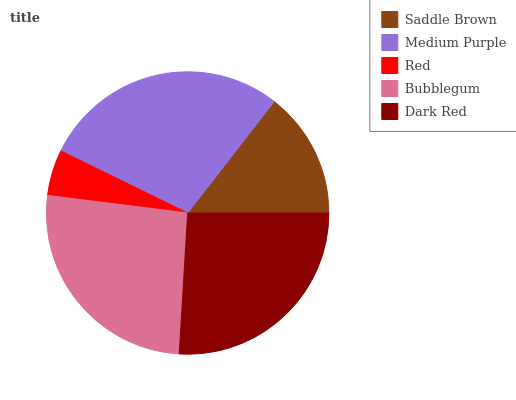Is Red the minimum?
Answer yes or no. Yes. Is Medium Purple the maximum?
Answer yes or no. Yes. Is Medium Purple the minimum?
Answer yes or no. No. Is Red the maximum?
Answer yes or no. No. Is Medium Purple greater than Red?
Answer yes or no. Yes. Is Red less than Medium Purple?
Answer yes or no. Yes. Is Red greater than Medium Purple?
Answer yes or no. No. Is Medium Purple less than Red?
Answer yes or no. No. Is Dark Red the high median?
Answer yes or no. Yes. Is Dark Red the low median?
Answer yes or no. Yes. Is Medium Purple the high median?
Answer yes or no. No. Is Saddle Brown the low median?
Answer yes or no. No. 